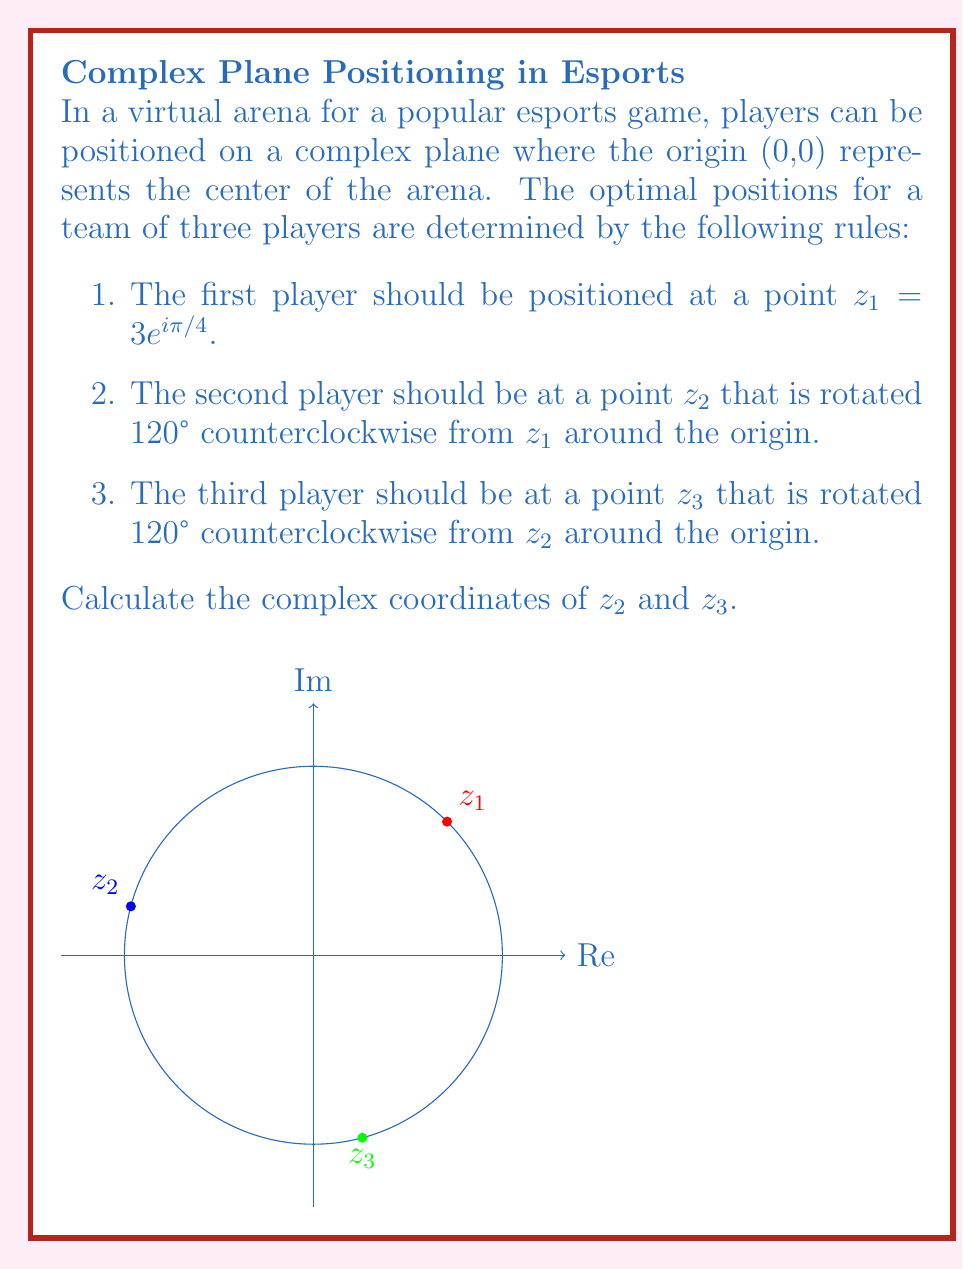Teach me how to tackle this problem. Let's approach this step-by-step:

1) We're given that $z_1 = 3e^{i\pi/4}$.

2) To rotate a complex number by an angle $\theta$ counterclockwise, we multiply it by $e^{i\theta}$.

3) For $z_2$, we need to rotate $z_1$ by 120° = $2\pi/3$ radians:

   $z_2 = z_1 \cdot e^{2\pi i/3} = 3e^{i\pi/4} \cdot e^{2\pi i/3} = 3e^{i(5\pi/4)}$

4) For $z_3$, we rotate $z_2$ by another 120°:

   $z_3 = z_2 \cdot e^{2\pi i/3} = 3e^{i(5\pi/4)} \cdot e^{2\pi i/3} = 3e^{i(3\pi/2)}$

5) We can express these in rectangular form:

   $z_2 = 3e^{i(5\pi/4)} = 3(\cos(5\pi/4) + i\sin(5\pi/4)) = -3\sqrt{2}/2 - 3\sqrt{2}i/2$

   $z_3 = 3e^{i(3\pi/2)} = 3(\cos(3\pi/2) + i\sin(3\pi/2)) = -3i$
Answer: $z_2 = -3\sqrt{2}/2 - 3\sqrt{2}i/2$, $z_3 = -3i$ 